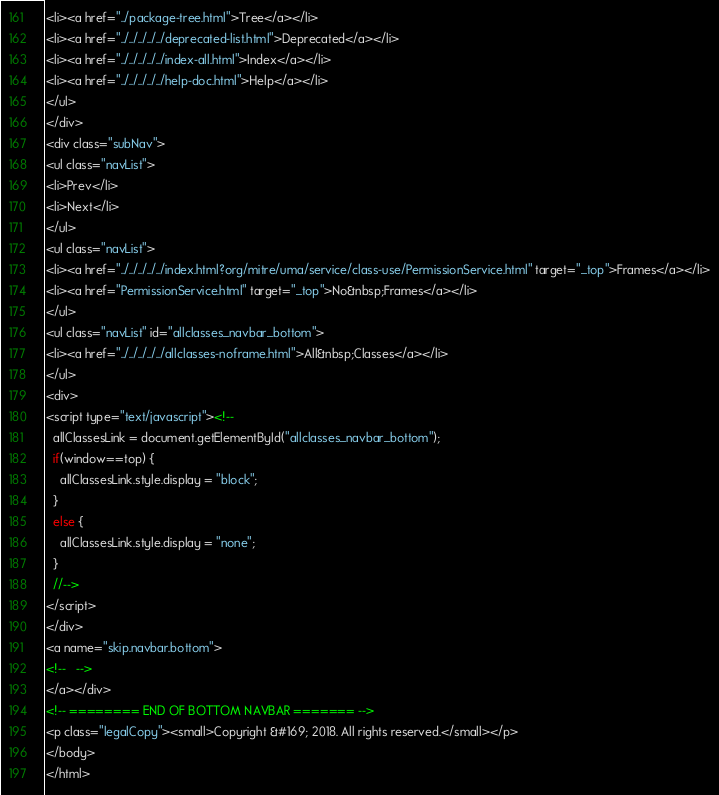<code> <loc_0><loc_0><loc_500><loc_500><_HTML_><li><a href="../package-tree.html">Tree</a></li>
<li><a href="../../../../../deprecated-list.html">Deprecated</a></li>
<li><a href="../../../../../index-all.html">Index</a></li>
<li><a href="../../../../../help-doc.html">Help</a></li>
</ul>
</div>
<div class="subNav">
<ul class="navList">
<li>Prev</li>
<li>Next</li>
</ul>
<ul class="navList">
<li><a href="../../../../../index.html?org/mitre/uma/service/class-use/PermissionService.html" target="_top">Frames</a></li>
<li><a href="PermissionService.html" target="_top">No&nbsp;Frames</a></li>
</ul>
<ul class="navList" id="allclasses_navbar_bottom">
<li><a href="../../../../../allclasses-noframe.html">All&nbsp;Classes</a></li>
</ul>
<div>
<script type="text/javascript"><!--
  allClassesLink = document.getElementById("allclasses_navbar_bottom");
  if(window==top) {
    allClassesLink.style.display = "block";
  }
  else {
    allClassesLink.style.display = "none";
  }
  //-->
</script>
</div>
<a name="skip.navbar.bottom">
<!--   -->
</a></div>
<!-- ======== END OF BOTTOM NAVBAR ======= -->
<p class="legalCopy"><small>Copyright &#169; 2018. All rights reserved.</small></p>
</body>
</html>
</code> 